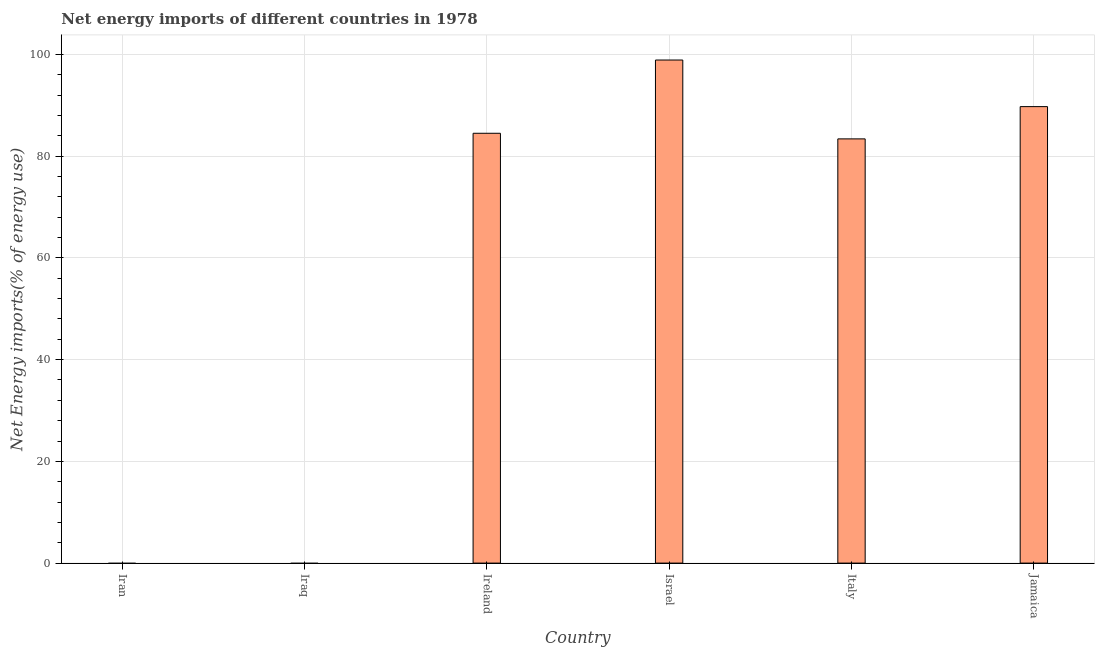Does the graph contain any zero values?
Make the answer very short. Yes. What is the title of the graph?
Your answer should be compact. Net energy imports of different countries in 1978. What is the label or title of the Y-axis?
Offer a terse response. Net Energy imports(% of energy use). What is the energy imports in Iran?
Give a very brief answer. 0. Across all countries, what is the maximum energy imports?
Ensure brevity in your answer.  98.91. What is the sum of the energy imports?
Ensure brevity in your answer.  356.57. What is the difference between the energy imports in Italy and Jamaica?
Offer a very short reply. -6.34. What is the average energy imports per country?
Your answer should be very brief. 59.43. What is the median energy imports?
Your response must be concise. 83.96. In how many countries, is the energy imports greater than 96 %?
Your answer should be very brief. 1. What is the ratio of the energy imports in Israel to that in Italy?
Ensure brevity in your answer.  1.19. Is the energy imports in Ireland less than that in Italy?
Provide a succinct answer. No. What is the difference between the highest and the second highest energy imports?
Ensure brevity in your answer.  9.16. What is the difference between the highest and the lowest energy imports?
Provide a succinct answer. 98.91. How many bars are there?
Offer a terse response. 4. Are all the bars in the graph horizontal?
Provide a short and direct response. No. How many countries are there in the graph?
Provide a short and direct response. 6. What is the difference between two consecutive major ticks on the Y-axis?
Offer a terse response. 20. Are the values on the major ticks of Y-axis written in scientific E-notation?
Provide a succinct answer. No. What is the Net Energy imports(% of energy use) of Ireland?
Provide a succinct answer. 84.51. What is the Net Energy imports(% of energy use) in Israel?
Your answer should be compact. 98.91. What is the Net Energy imports(% of energy use) of Italy?
Keep it short and to the point. 83.41. What is the Net Energy imports(% of energy use) in Jamaica?
Make the answer very short. 89.75. What is the difference between the Net Energy imports(% of energy use) in Ireland and Israel?
Keep it short and to the point. -14.4. What is the difference between the Net Energy imports(% of energy use) in Ireland and Italy?
Offer a very short reply. 1.1. What is the difference between the Net Energy imports(% of energy use) in Ireland and Jamaica?
Your response must be concise. -5.24. What is the difference between the Net Energy imports(% of energy use) in Israel and Italy?
Ensure brevity in your answer.  15.5. What is the difference between the Net Energy imports(% of energy use) in Israel and Jamaica?
Ensure brevity in your answer.  9.16. What is the difference between the Net Energy imports(% of energy use) in Italy and Jamaica?
Offer a terse response. -6.34. What is the ratio of the Net Energy imports(% of energy use) in Ireland to that in Israel?
Give a very brief answer. 0.85. What is the ratio of the Net Energy imports(% of energy use) in Ireland to that in Jamaica?
Keep it short and to the point. 0.94. What is the ratio of the Net Energy imports(% of energy use) in Israel to that in Italy?
Provide a succinct answer. 1.19. What is the ratio of the Net Energy imports(% of energy use) in Israel to that in Jamaica?
Your answer should be compact. 1.1. What is the ratio of the Net Energy imports(% of energy use) in Italy to that in Jamaica?
Keep it short and to the point. 0.93. 